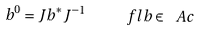Convert formula to latex. <formula><loc_0><loc_0><loc_500><loc_500>b ^ { 0 } = J b ^ { * } J ^ { - 1 } \quad \ f l b \in \ A c</formula> 